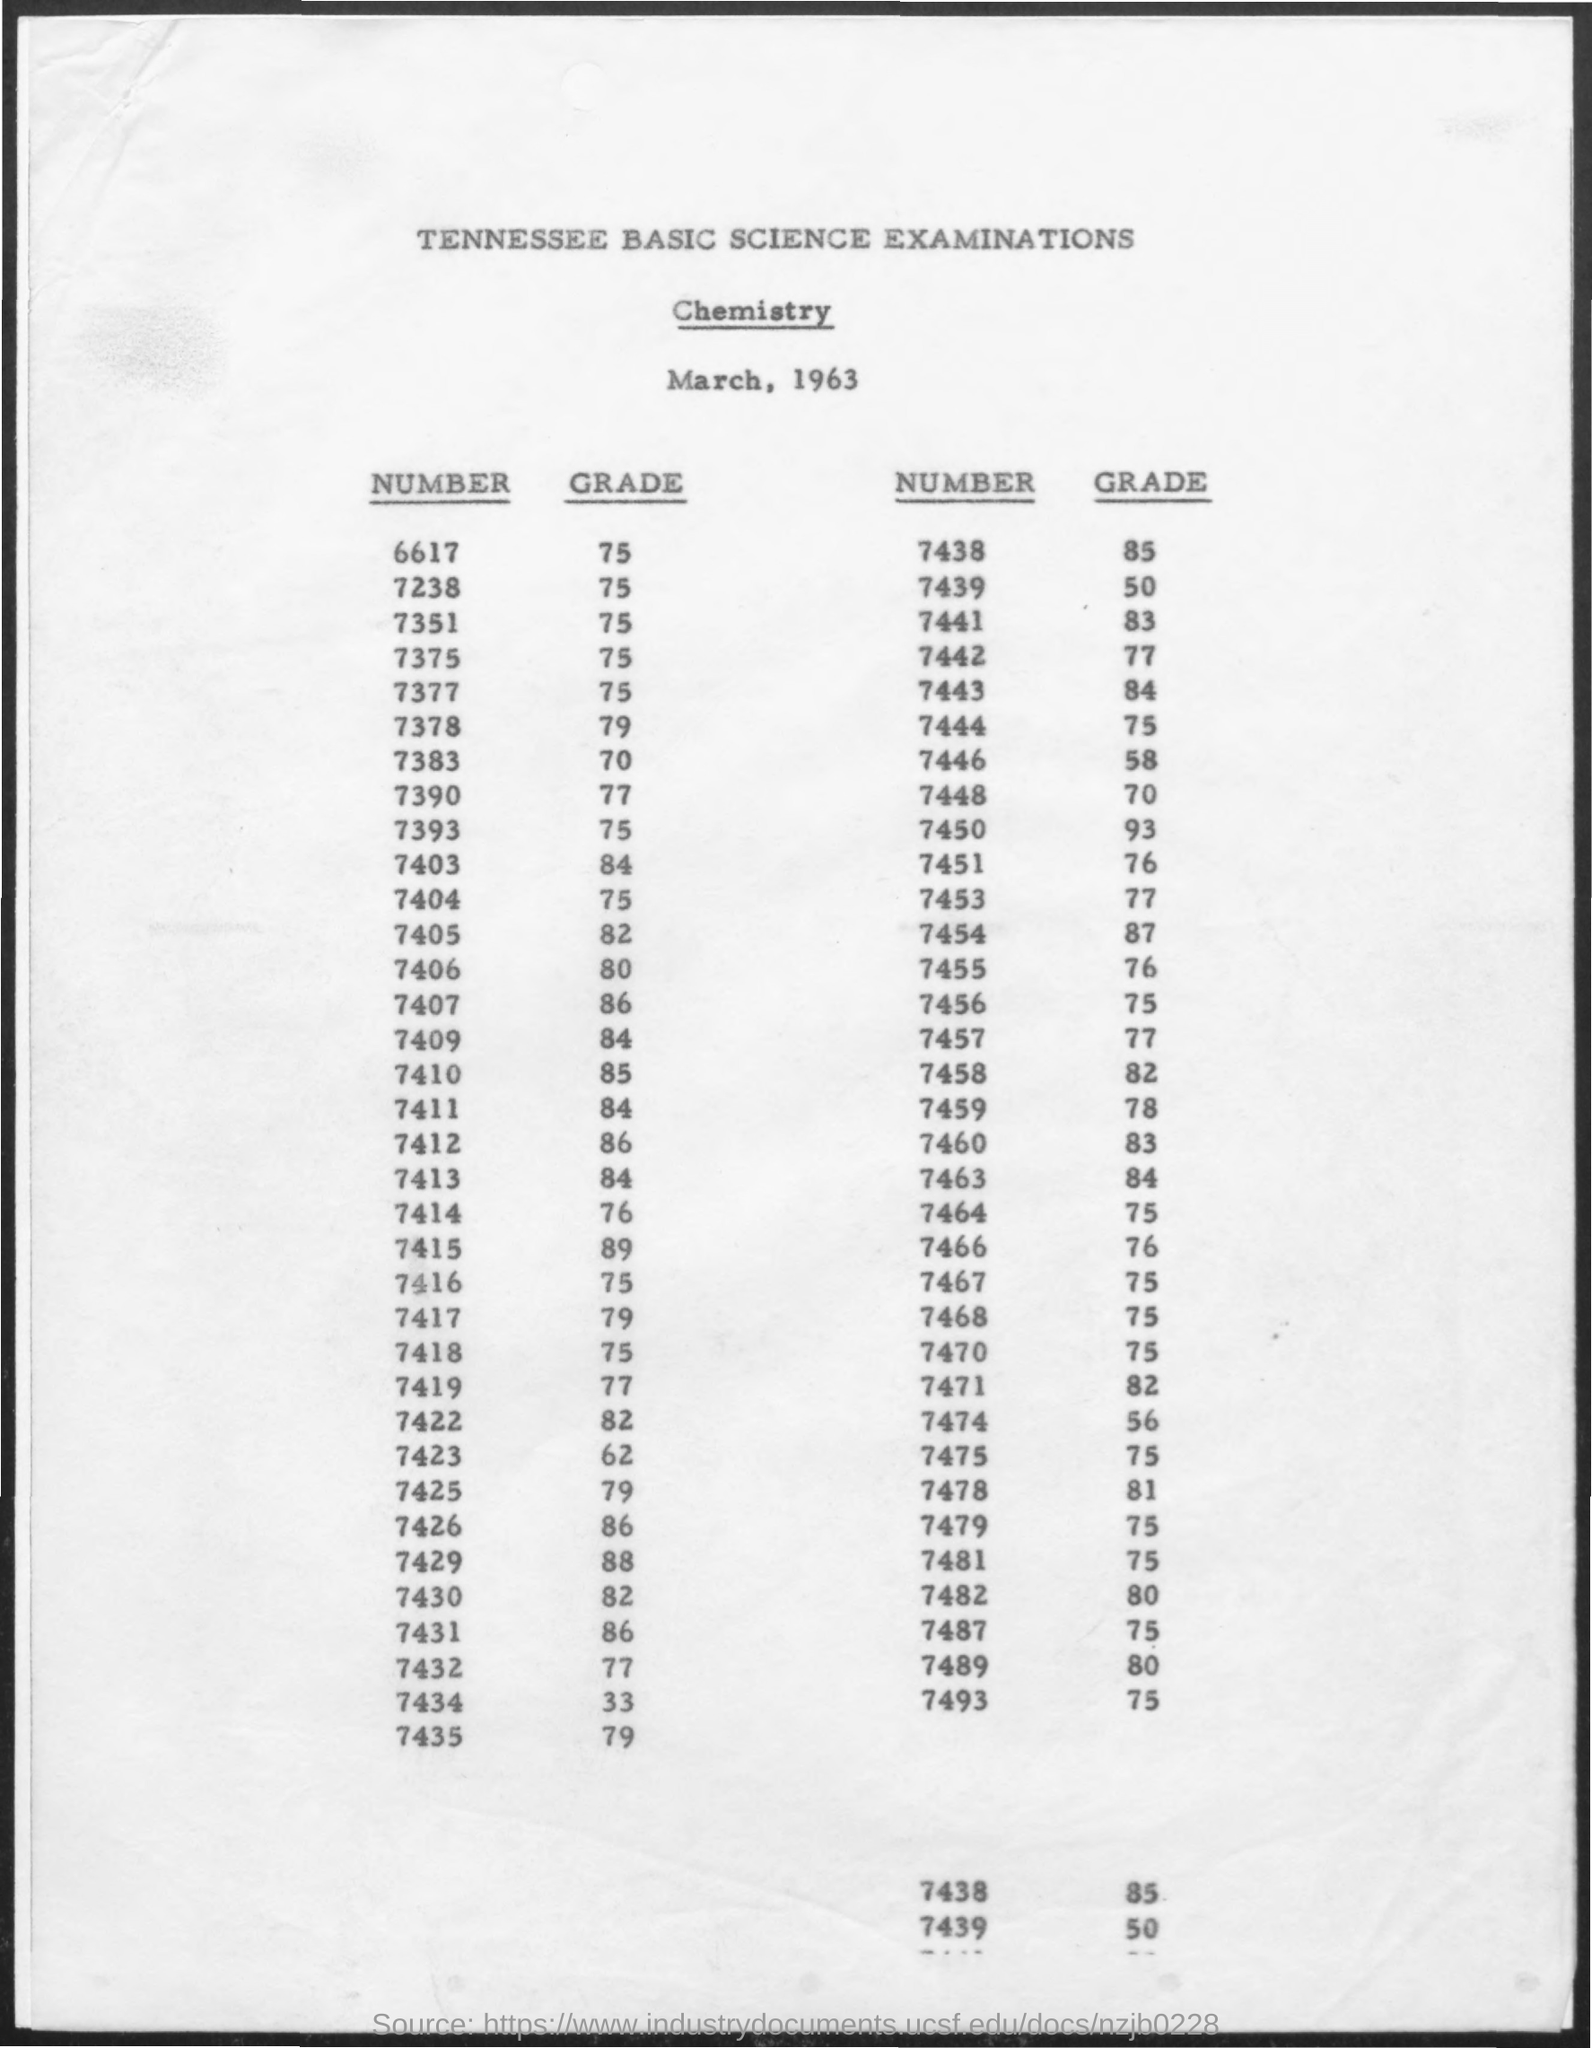How many students scored above 80 on this examination? After reviewing the scores, it appears that 16 students scored above 80 on this chemistry exam. 